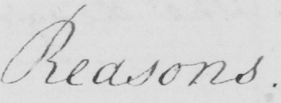Can you read and transcribe this handwriting? Reasons . 